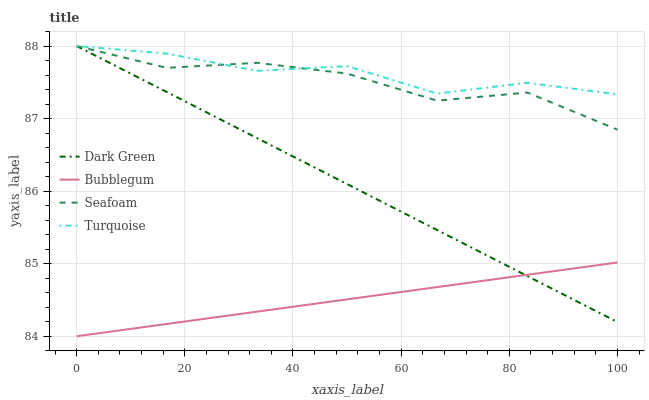Does Bubblegum have the minimum area under the curve?
Answer yes or no. Yes. Does Turquoise have the maximum area under the curve?
Answer yes or no. Yes. Does Seafoam have the minimum area under the curve?
Answer yes or no. No. Does Seafoam have the maximum area under the curve?
Answer yes or no. No. Is Bubblegum the smoothest?
Answer yes or no. Yes. Is Seafoam the roughest?
Answer yes or no. Yes. Is Seafoam the smoothest?
Answer yes or no. No. Is Bubblegum the roughest?
Answer yes or no. No. Does Bubblegum have the lowest value?
Answer yes or no. Yes. Does Seafoam have the lowest value?
Answer yes or no. No. Does Dark Green have the highest value?
Answer yes or no. Yes. Does Bubblegum have the highest value?
Answer yes or no. No. Is Bubblegum less than Seafoam?
Answer yes or no. Yes. Is Seafoam greater than Bubblegum?
Answer yes or no. Yes. Does Turquoise intersect Seafoam?
Answer yes or no. Yes. Is Turquoise less than Seafoam?
Answer yes or no. No. Is Turquoise greater than Seafoam?
Answer yes or no. No. Does Bubblegum intersect Seafoam?
Answer yes or no. No. 